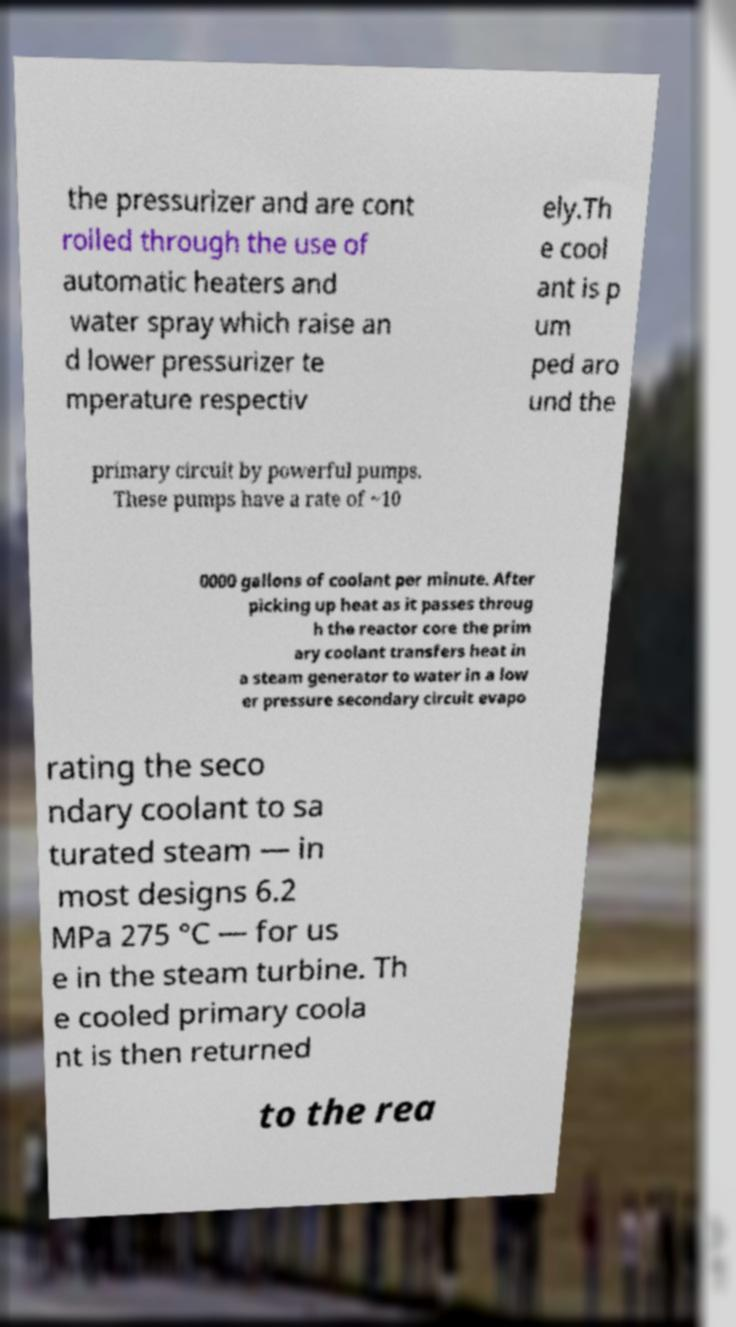I need the written content from this picture converted into text. Can you do that? the pressurizer and are cont rolled through the use of automatic heaters and water spray which raise an d lower pressurizer te mperature respectiv ely.Th e cool ant is p um ped aro und the primary circuit by powerful pumps. These pumps have a rate of ~10 0000 gallons of coolant per minute. After picking up heat as it passes throug h the reactor core the prim ary coolant transfers heat in a steam generator to water in a low er pressure secondary circuit evapo rating the seco ndary coolant to sa turated steam — in most designs 6.2 MPa 275 °C — for us e in the steam turbine. Th e cooled primary coola nt is then returned to the rea 